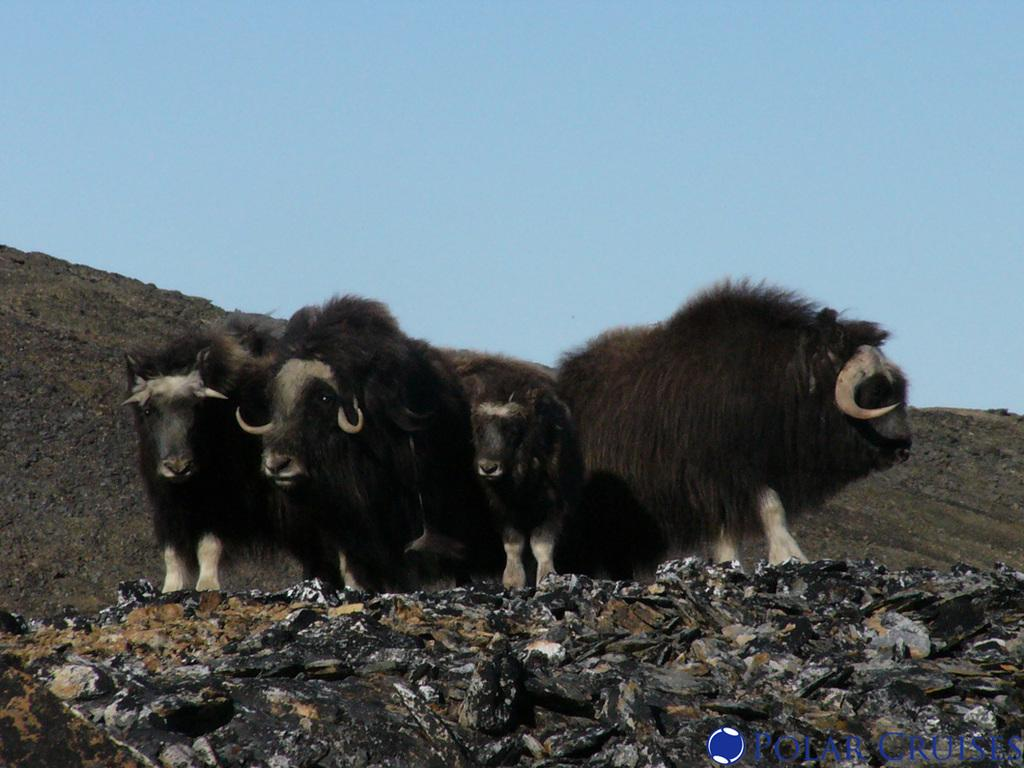What can be seen on the surface in the image? There are animals on the surface in the image. What geographical feature is visible in the background of the image? There is a hill visible in the background of the image. What else can be seen in the background of the image? The sky is visible in the background of the image. Where is the text located in the image? The text is in the bottom right side of the image. What type of iron is being used by the animals in the image? There is no iron present in the image; it features animals on a surface with a hill and sky in the background. How many seeds can be seen falling from the sky in the image? There are no seeds falling from the sky in the image; it only shows animals, a hill, and the sky. 